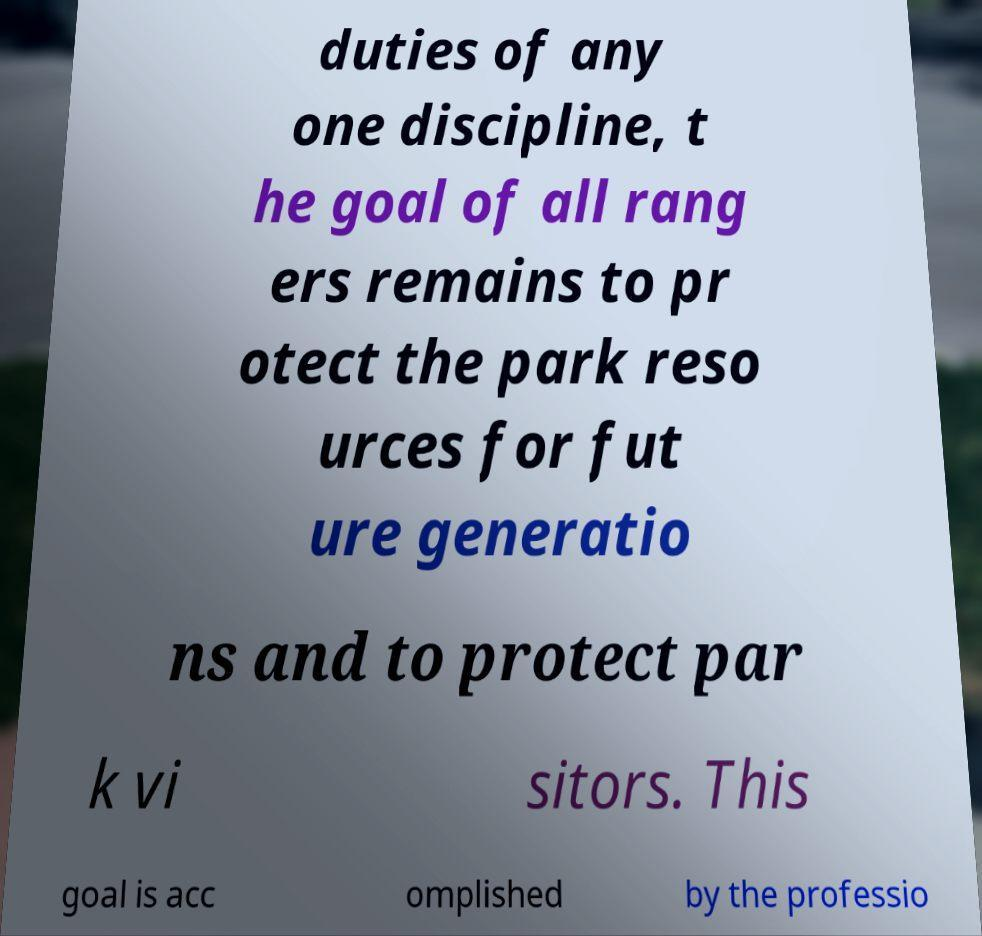Please identify and transcribe the text found in this image. duties of any one discipline, t he goal of all rang ers remains to pr otect the park reso urces for fut ure generatio ns and to protect par k vi sitors. This goal is acc omplished by the professio 